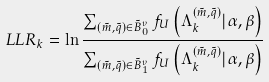Convert formula to latex. <formula><loc_0><loc_0><loc_500><loc_500>L L R _ { k } = \ln \frac { \sum _ { ( \tilde { m } , \tilde { q } ) \in \tilde { B } _ { 0 } ^ { \upsilon } } f _ { U } \left ( \mathbf \Lambda _ { k } ^ { ( \tilde { m } , \tilde { q } ) } | \alpha , \beta \right ) } { \sum _ { ( \tilde { m } , \tilde { q } ) \in \tilde { B } _ { 1 } ^ { \upsilon } } f _ { U } \left ( \mathbf \Lambda _ { k } ^ { ( \tilde { m } , \tilde { q } ) } | \alpha , \beta \right ) }</formula> 